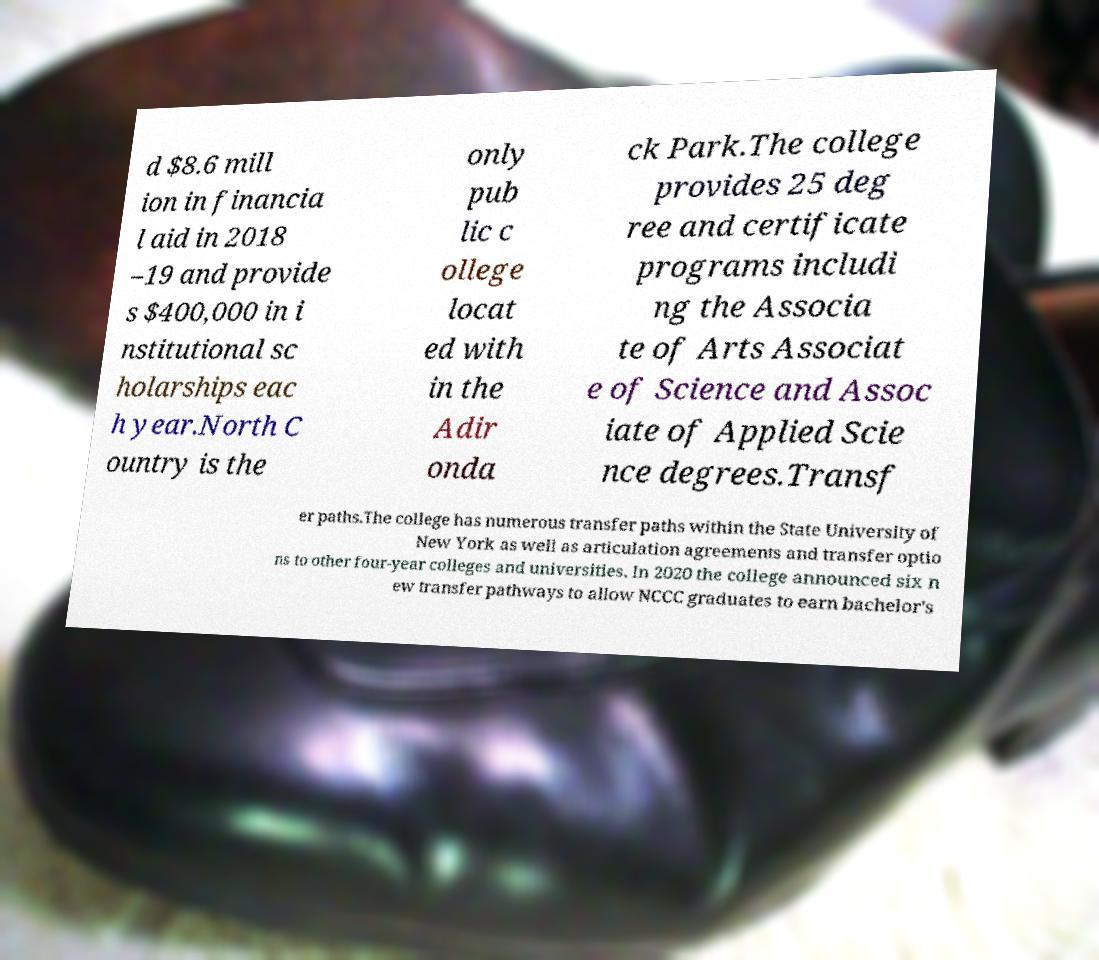Please identify and transcribe the text found in this image. d $8.6 mill ion in financia l aid in 2018 –19 and provide s $400,000 in i nstitutional sc holarships eac h year.North C ountry is the only pub lic c ollege locat ed with in the Adir onda ck Park.The college provides 25 deg ree and certificate programs includi ng the Associa te of Arts Associat e of Science and Assoc iate of Applied Scie nce degrees.Transf er paths.The college has numerous transfer paths within the State University of New York as well as articulation agreements and transfer optio ns to other four-year colleges and universities. In 2020 the college announced six n ew transfer pathways to allow NCCC graduates to earn bachelor's 